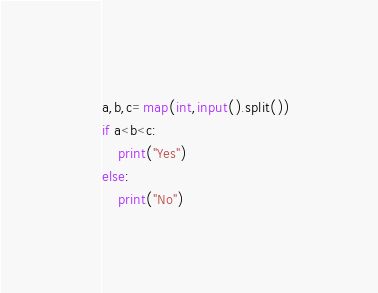<code> <loc_0><loc_0><loc_500><loc_500><_Python_>a,b,c=map(int,input().split())
if a<b<c:
    print("Yes")
else:
    print("No")
</code> 